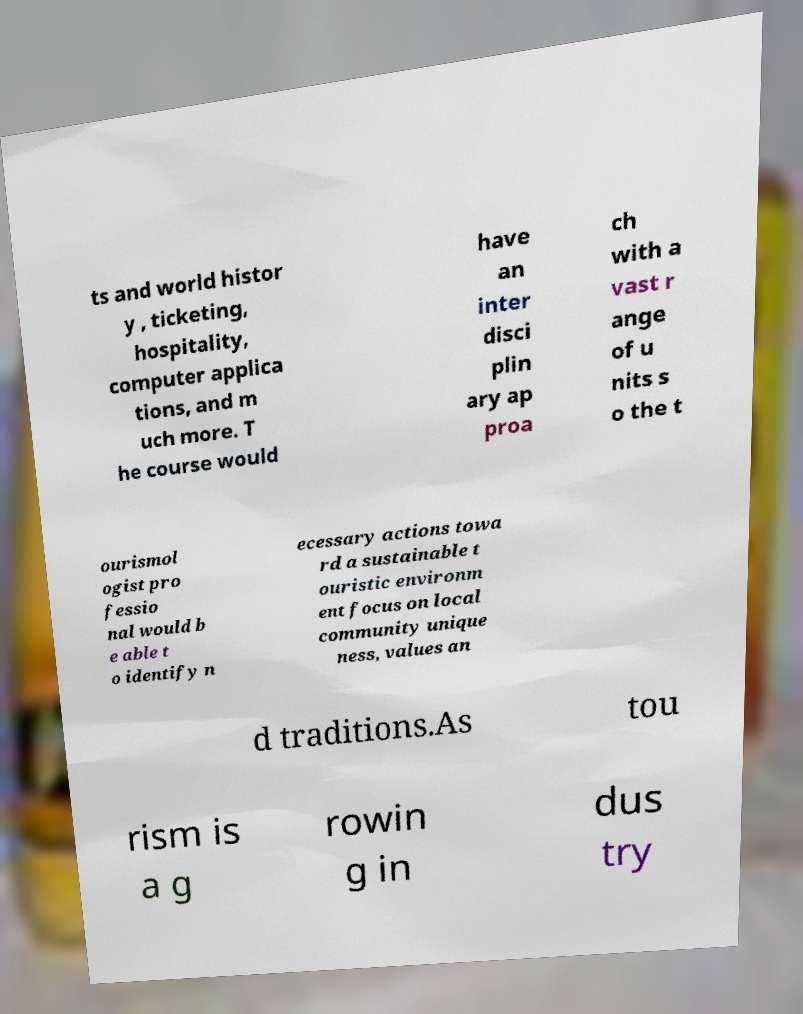I need the written content from this picture converted into text. Can you do that? ts and world histor y , ticketing, hospitality, computer applica tions, and m uch more. T he course would have an inter disci plin ary ap proa ch with a vast r ange of u nits s o the t ourismol ogist pro fessio nal would b e able t o identify n ecessary actions towa rd a sustainable t ouristic environm ent focus on local community unique ness, values an d traditions.As tou rism is a g rowin g in dus try 